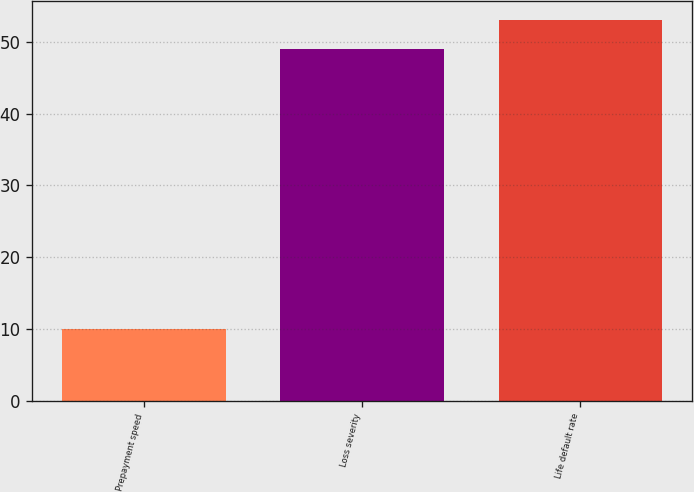Convert chart to OTSL. <chart><loc_0><loc_0><loc_500><loc_500><bar_chart><fcel>Prepayment speed<fcel>Loss severity<fcel>Life default rate<nl><fcel>10<fcel>49<fcel>53<nl></chart> 